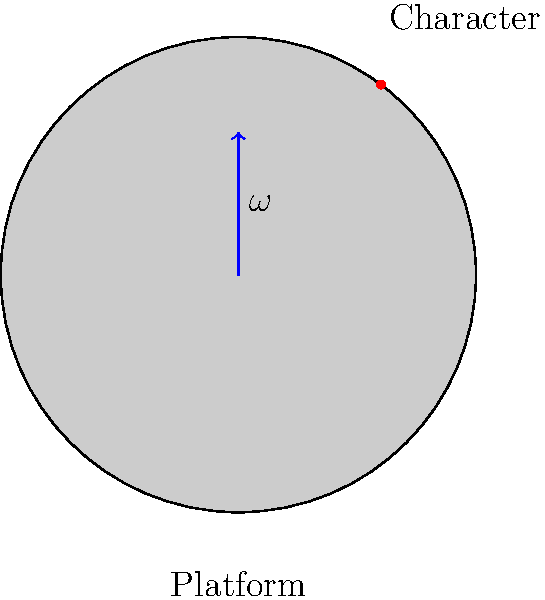In your indie platformer, a character stands on a circular platform spinning with an angular velocity $\omega = 2$ rad/s. If the character is positioned 0.5 meters from the center of the platform, what is the magnitude of the character's tangential velocity? How would this affect the character's movement in the game? To solve this problem, we'll follow these steps:

1. Recall the formula for tangential velocity:
   $v = r \omega$
   where $v$ is tangential velocity, $r$ is the radius, and $\omega$ is angular velocity.

2. We're given:
   $\omega = 2$ rad/s
   $r = 0.5$ m

3. Plug these values into the formula:
   $v = 0.5 \text{ m} \cdot 2 \text{ rad/s} = 1 \text{ m/s}$

4. Game design implications:
   - The character will experience a constant sideways force due to the platform's rotation.
   - This force could make the character slide off the platform if there's no friction.
   - The player might need to continuously adjust the character's position to stay on the platform.
   - You could use this mechanic to create challenging levels where timing and positioning are crucial.
   - The rotation could affect jump trajectories, making precision platforming more complex.

5. Possible gameplay mechanics:
   - Implement a "grip" or "magnetism" feature to help the character stay on the platform.
   - Use the rotation to fling the character to reach new areas.
   - Create puzzles where the player must use the rotation to their advantage.
Answer: 1 m/s; creates constant sideways force, affecting character positioning and jump trajectories. 